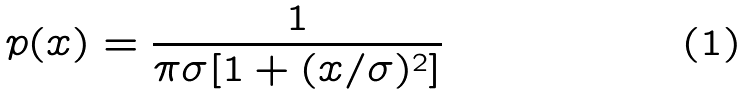Convert formula to latex. <formula><loc_0><loc_0><loc_500><loc_500>p ( x ) = \frac { 1 } { \pi \sigma [ 1 + ( x / \sigma ) ^ { 2 } ] }</formula> 